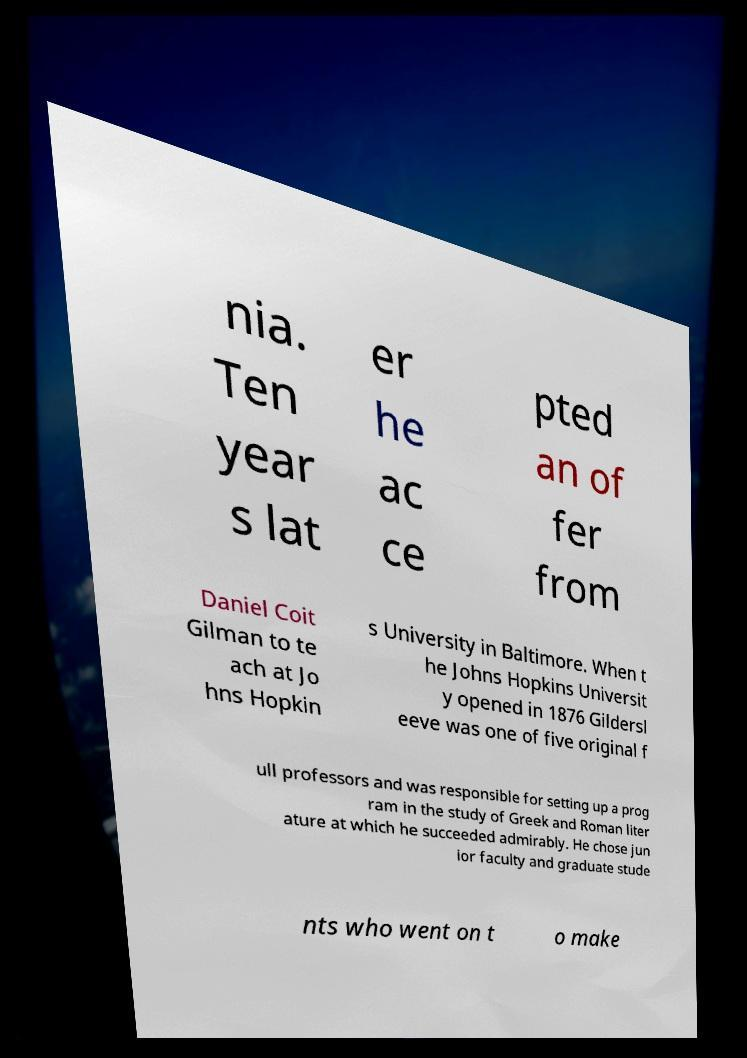Could you assist in decoding the text presented in this image and type it out clearly? nia. Ten year s lat er he ac ce pted an of fer from Daniel Coit Gilman to te ach at Jo hns Hopkin s University in Baltimore. When t he Johns Hopkins Universit y opened in 1876 Gildersl eeve was one of five original f ull professors and was responsible for setting up a prog ram in the study of Greek and Roman liter ature at which he succeeded admirably. He chose jun ior faculty and graduate stude nts who went on t o make 